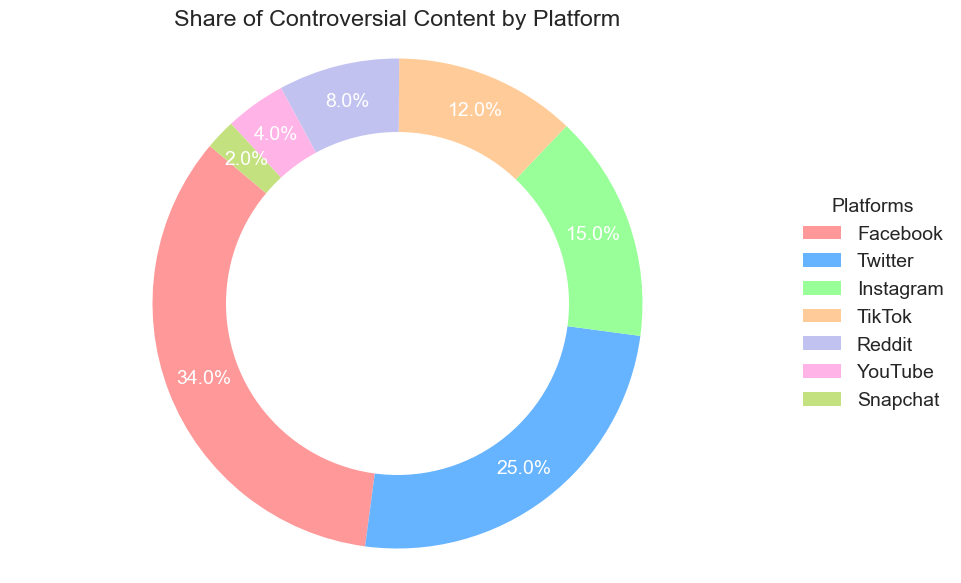Which platform has the highest share of controversial content? The figure shows that Facebook has the largest section in the pie chart, labeled with a percentage higher than any other platform.
Answer: Facebook Which two platforms combined have a controversial content share of 40%? From the pie chart, Twitter has a 25% share and Instagram has a 15% share. Adding these percentages gives 25% + 15% = 40%.
Answer: Twitter and Instagram What is the difference in controversial content share between the top and bottom platforms? The chart shows that Facebook has a 34% share, and Snapchat has a 2% share. The difference is 34% - 2% = 32%.
Answer: 32% Which platform has a smaller share of controversial content, YouTube or Reddit? Comparing the sections, YouTube has a 4% share, and Reddit has an 8% share. 4% is smaller than 8%.
Answer: YouTube What is the combined controversial content share of TikTok, Reddit, and YouTube? The chart shows TikTok at 12%, Reddit at 8%, and YouTube at 4%. Adding these gives 12% + 8% + 4% = 24%.
Answer: 24% Which platform has a share that is double the controversial content share of YouTube? YouTube has a 4% share. Doubling this would be 4% * 2 = 8%. The chart shows that Reddit has an 8% share.
Answer: Reddit How much higher is Facebook's share compared to TikTok's? The figure shows Facebook at 34% and TikTok at 12%. The difference is 34% - 12% = 22%.
Answer: 22% Which platform is represented by the green section of the pie chart? The figure should visually distinguish sections by color. Assuming consistency, the green section corresponds to one of the predefined colors and platforms. After viewing, it's Instagram.
Answer: Instagram 